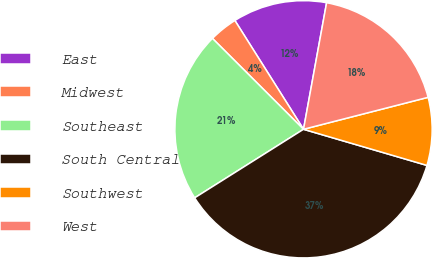Convert chart. <chart><loc_0><loc_0><loc_500><loc_500><pie_chart><fcel>East<fcel>Midwest<fcel>Southeast<fcel>South Central<fcel>Southwest<fcel>West<nl><fcel>11.83%<fcel>3.56%<fcel>21.43%<fcel>36.52%<fcel>8.53%<fcel>18.13%<nl></chart> 